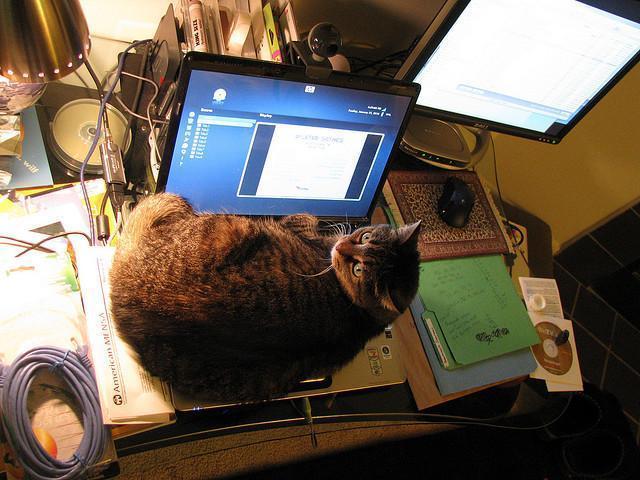How many computer monitors are shown?
Give a very brief answer. 2. How many tvs can be seen?
Give a very brief answer. 2. How many books can you see?
Give a very brief answer. 2. 